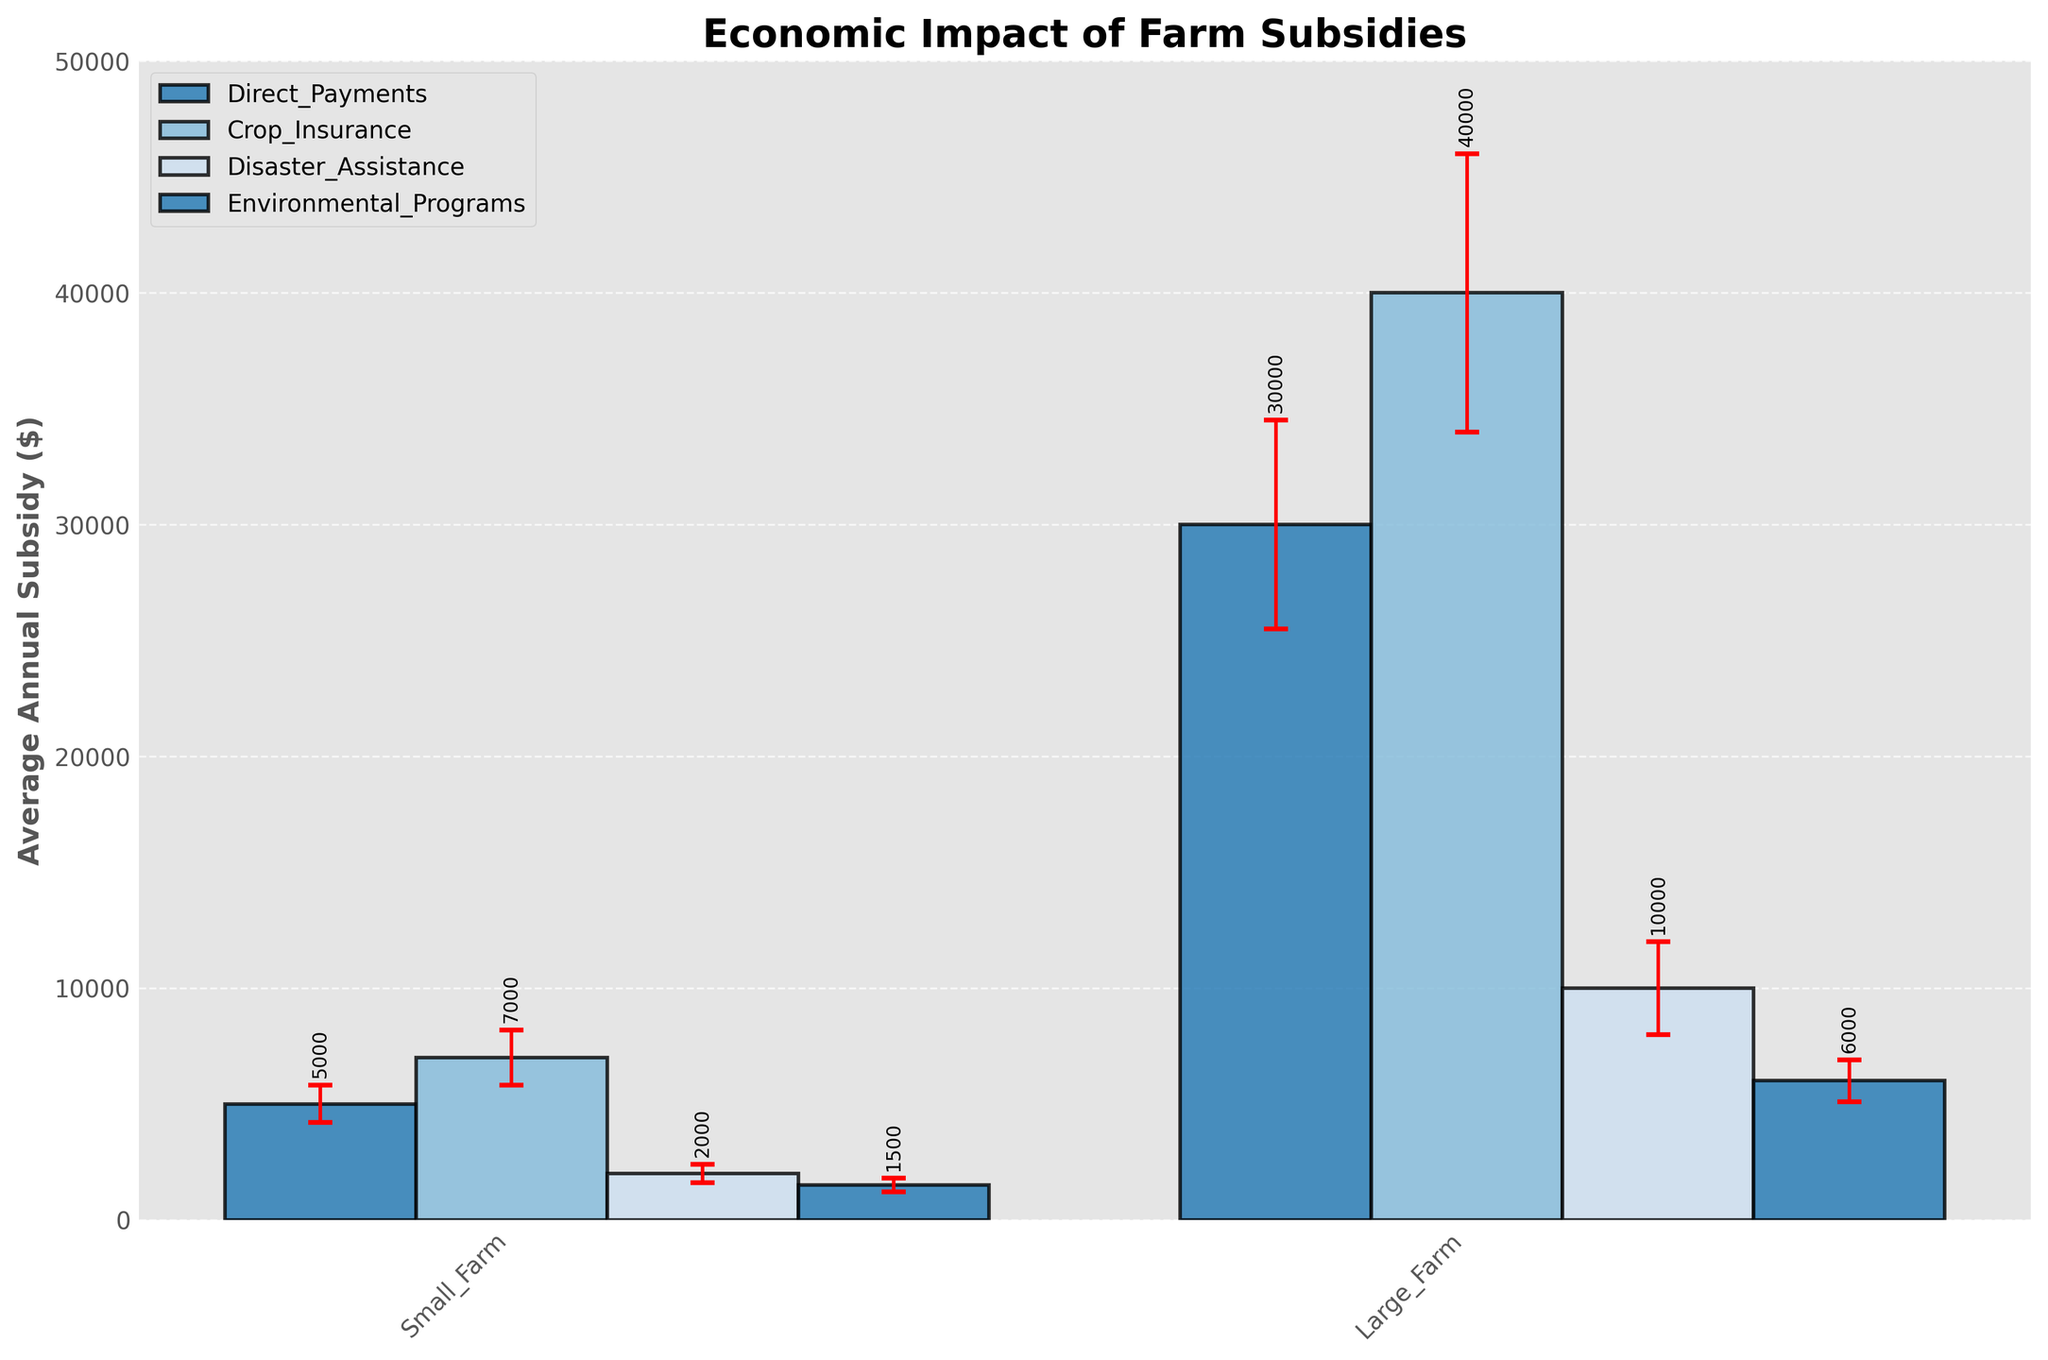What is the title of the figure? The title of the figure is displayed prominently at the top. It provides context to the entire plot, indicating what the viewer should expect to learn from the plot.
Answer: Economic Impact of Farm Subsidies What does the y-axis represent? The y-axis shows the average annual subsidy in dollars for different types of subsidies given to small and large farms. This helps measure the economic impact in monetary terms.
Answer: Average Annual Subsidy ($) Which subsidy type has the highest average annual subsidy for large farms, and what is the amount? By looking at the height of the bars representing large farms, the tallest bar corresponds to 'Crop Insurance' with an average annual subsidy amount shown by the y-axis measurement.
Answer: Crop Insurance, $40000 Which type of farm receives more in 'Disaster Assistance' subsidies on average? By comparing the bar heights for 'Disaster Assistance' between small and large farms, the larger bar represents the farm type receiving more subsidies.
Answer: Large Farm How much more, on average, do large farms receive in 'Direct Payments' than small farms? Find the average annual subsidy amounts for 'Direct Payments' for both farm types and subtract the smaller value from the larger one: $30000 (large) - $5000 (small) = $25000.
Answer: $25000 Which subsidy type has the smallest standard deviation for small farms, and what is the value? Review the error ranges (represented by the length of the error bars) for each subsidy type in small farms. The smallest error bar indicates the lowest standard deviation. Here, 'Environmental Programs' has the smallest error with a standard deviation of $300.
Answer: Environmental Programs, $300 What are the error ranges for 'Crop Insurance' subsidies for large farms? The standard deviation provides the error range. For large farms receiving 'Crop Insurance' subsidies, the standard deviation is $6000, so the error range is $40000 ± $6000.
Answer: $34000 to $46000 Compare the average annual subsidies received by small farms for 'Crop Insurance' and 'Disaster Assistance.' Which is greater, and by how much? Check the bar heights for 'Crop Insurance' and 'Disaster Assistance' for small farms. 'Crop Insurance' is at $7000, and 'Disaster Assistance' is at $2000. The difference is $7000 - $2000 = $5000.
Answer: Crop Insurance, by $5000 Which subsidy category has the largest difference in standard deviations between small and large farms? Evaluate standard deviations for each subsidy type for both farm sizes and calculate the differences. The largest difference in standard deviations is for 'Crop Insurance' with a difference of  $6000 - $1200 = $4800.
Answer: Crop Insurance, $4800 What is the combined average annual subsidy received by large farms for 'Disaster Assistance' and 'Environmental Programs'? Add the two relevant average annual subsidies together: $10000 (Disaster Assistance) + $6000 (Environmental Programs) = $16000.
Answer: $16000 